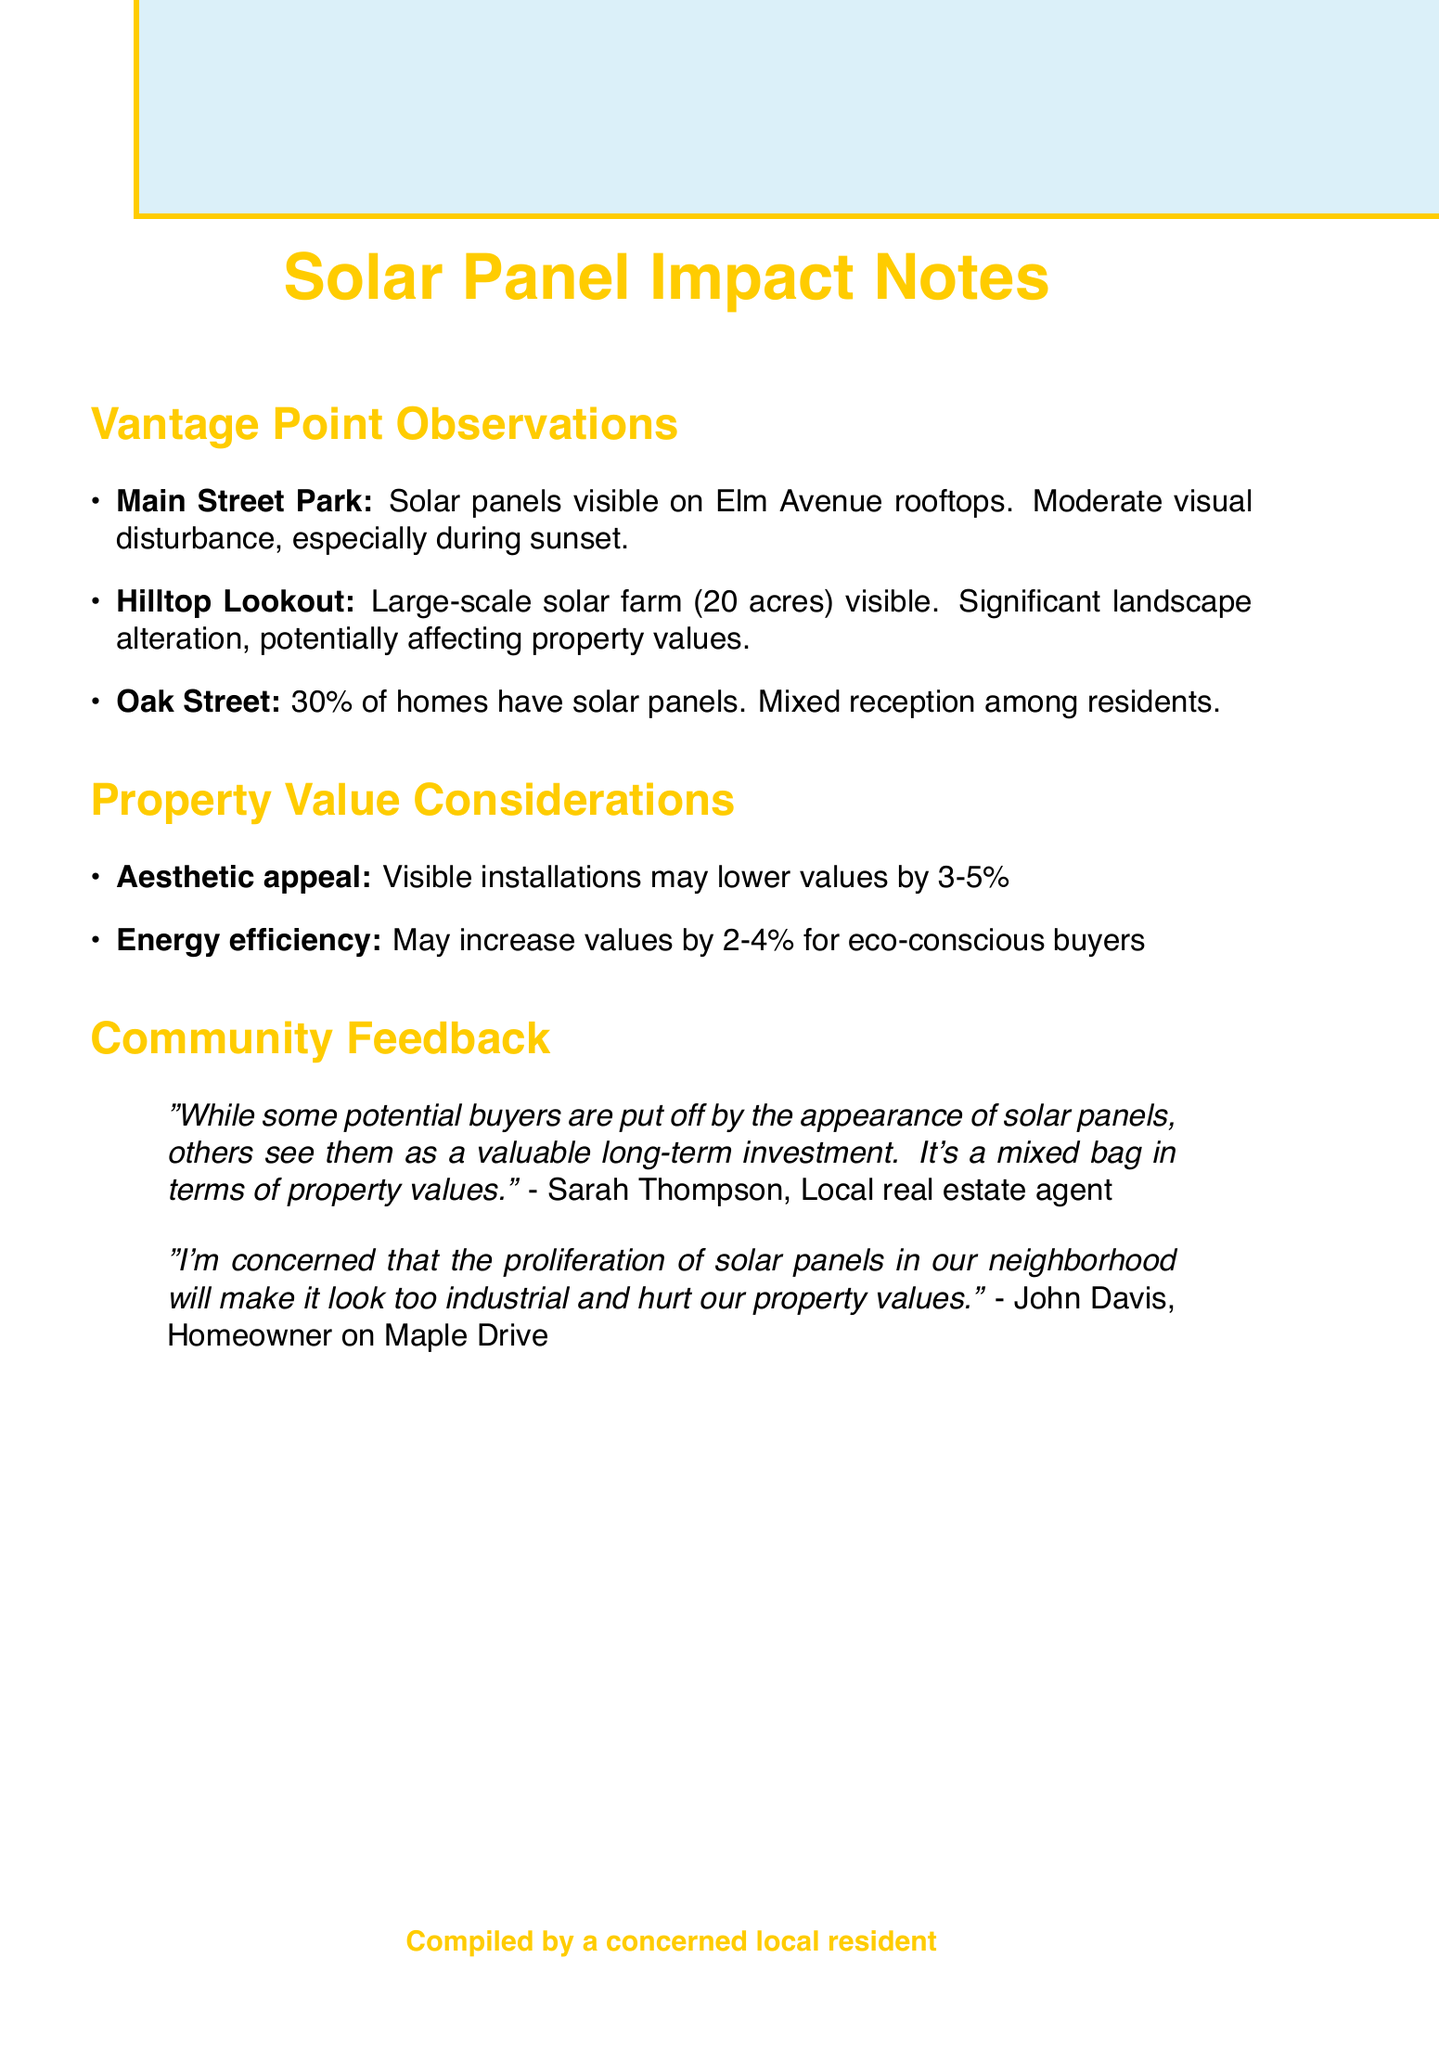What is the location of the solar panels observed from the Main Street Park? The solar panels are visible on the rooftops of houses along Elm Avenue from the Main Street Park.
Answer: Elm Avenue What is the size of the solar farm visible from Hilltop Lookout? The solar farm covers approximately 20 acres of previously undeveloped land.
Answer: 20 acres What percentage of homes in the Oak Street neighborhood have solar panels? Solar panels are installed on 30% of homes in the neighborhood on Oak Street.
Answer: 30% What is the potential property value decrease due to aesthetic appeal? Homes with visible solar installations may be less attractive to some buyers, potentially lowering property values by 3-5%.
Answer: 3-5% Who expressed concern about the visual impact of solar panels on property values? John Davis, a homeowner on Maple Drive, expressed concern regarding the solar panels making the neighborhood look too industrial.
Answer: John Davis What feedback did Sarah Thompson provide about solar panels and property values? Sarah Thompson stated that it's a mixed bag in terms of property values, as some buyers are put off while others see them as a valuable long-term investment.
Answer: Mixed bag What kind of visual disturbance is associated with the solar panels in the Main Street Park observation? The observation mentioned a moderate visual disturbance, particularly during sunset when panels reflect light.
Answer: Moderate visual disturbance What is the impact on property values due to energy efficiency? Houses with solar panels may attract environmentally conscious buyers, potentially increasing property values by 2-4%.
Answer: 2-4% 